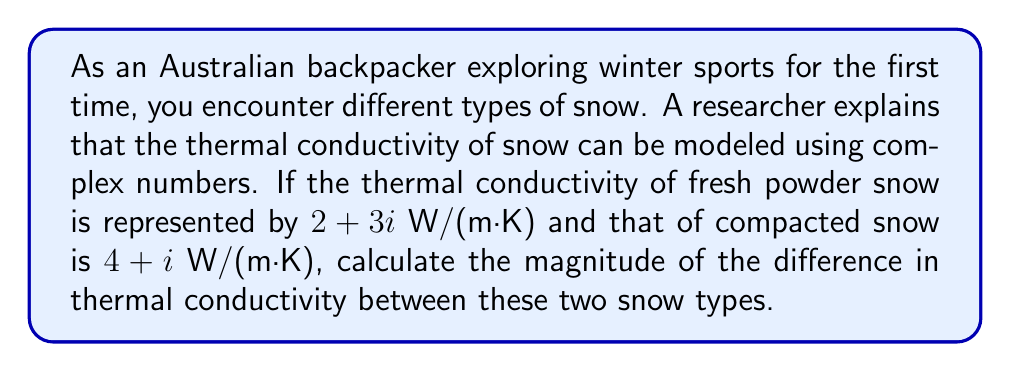Show me your answer to this math problem. Let's approach this step-by-step:

1) Let $z_1 = 2 + 3i$ represent the thermal conductivity of fresh powder snow
   Let $z_2 = 4 + i$ represent the thermal conductivity of compacted snow

2) To find the difference in thermal conductivity, we subtract:
   $z = z_2 - z_1 = (4 + i) - (2 + 3i) = 4 + i - 2 - 3i = 2 - 2i$

3) Now, we need to find the magnitude of this difference. For a complex number $a + bi$, the magnitude is given by $\sqrt{a^2 + b^2}$

4) In this case, $a = 2$ and $b = -2$

5) Calculating the magnitude:
   $|z| = \sqrt{2^2 + (-2)^2} = \sqrt{4 + 4} = \sqrt{8} = 2\sqrt{2}$

6) Therefore, the magnitude of the difference in thermal conductivity is $2\sqrt{2}$ W/(m·K)
Answer: $2\sqrt{2}$ W/(m·K) 